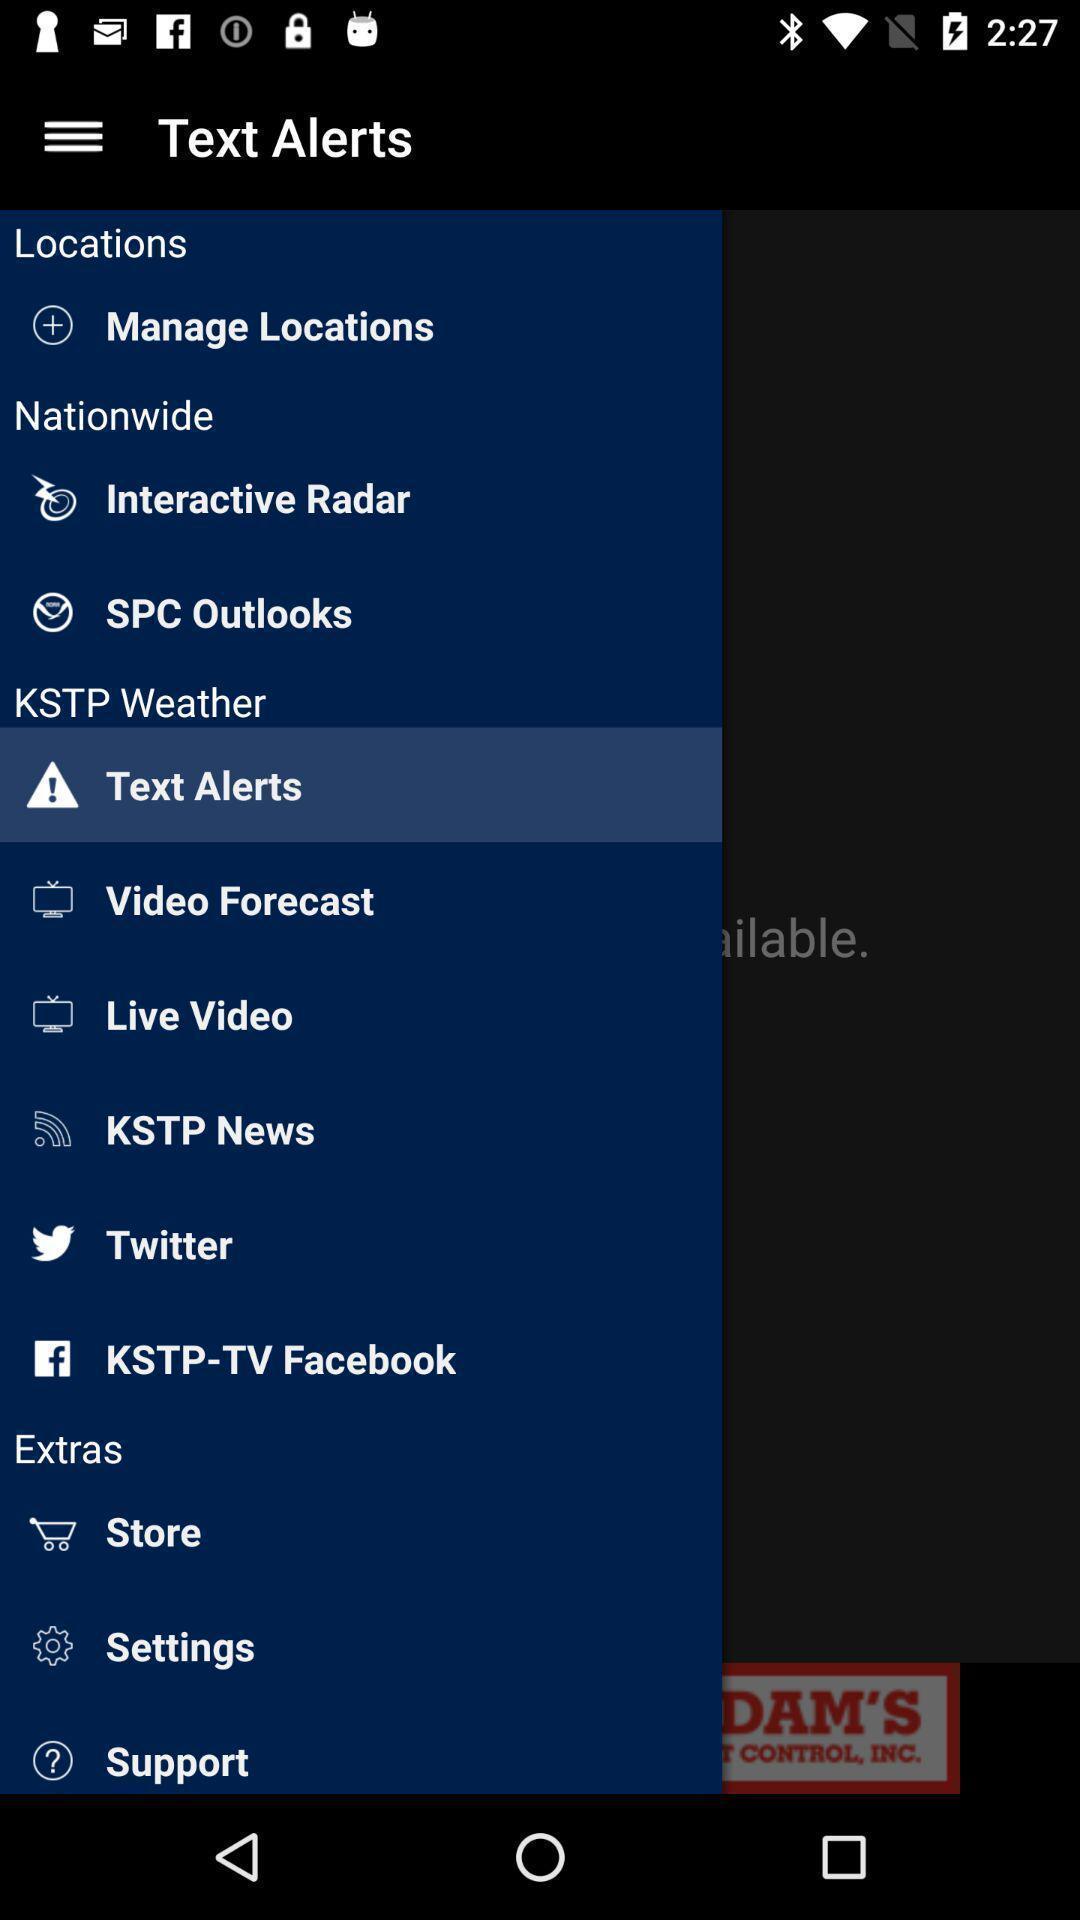What can you discern from this picture? Screen displaying multiple options. 